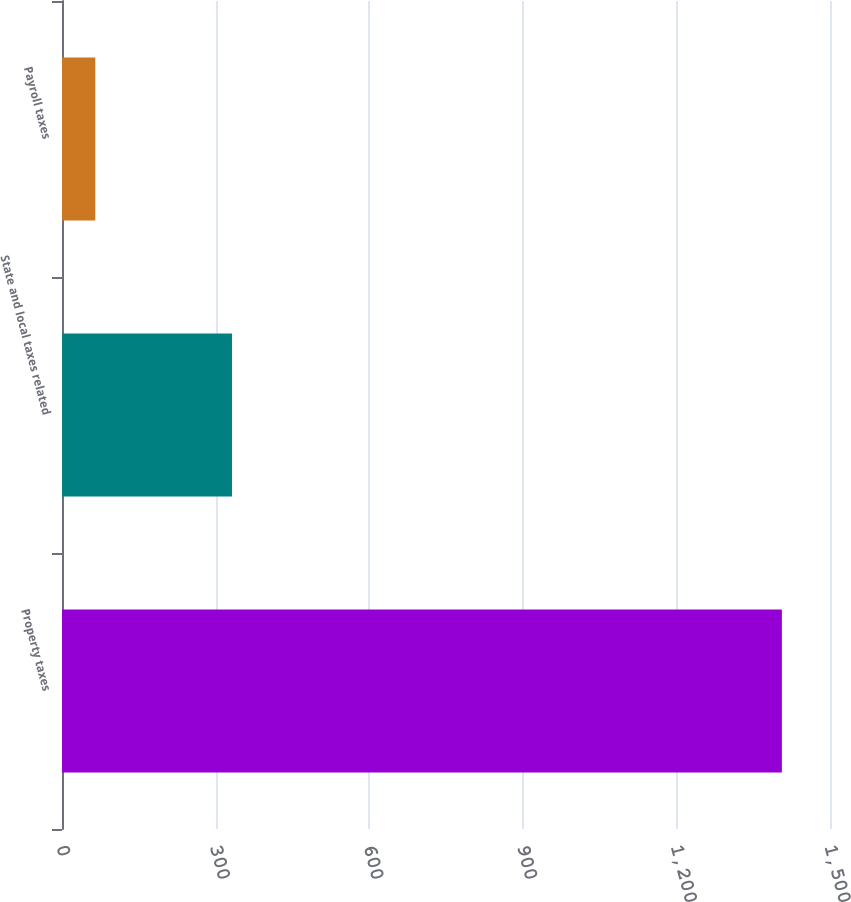Convert chart to OTSL. <chart><loc_0><loc_0><loc_500><loc_500><bar_chart><fcel>Property taxes<fcel>State and local taxes related<fcel>Payroll taxes<nl><fcel>1406<fcel>332<fcel>65<nl></chart> 